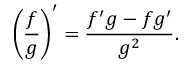<formula> <loc_0><loc_0><loc_500><loc_500>{ \left ( { \frac { f } { g } } \right ) } ^ { \prime } = { \frac { f ^ { \prime } g - f g ^ { \prime } } { g ^ { 2 } } } .</formula> 